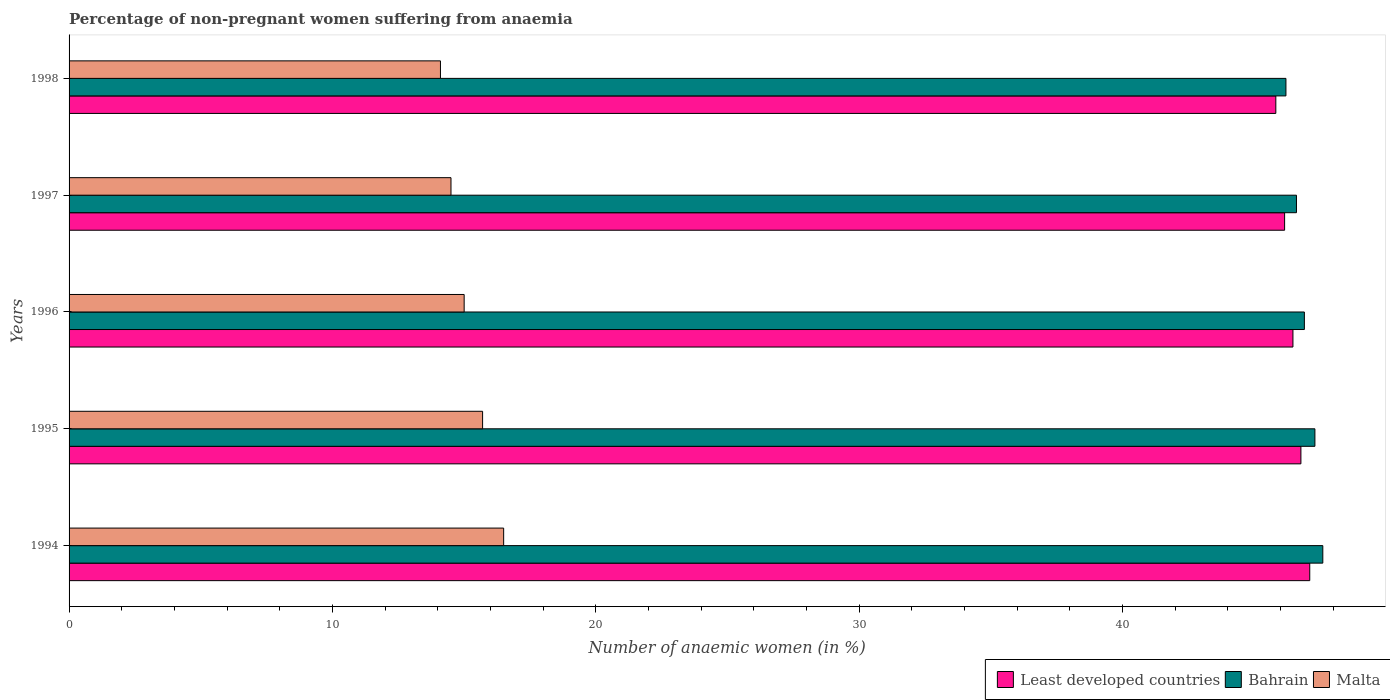How many groups of bars are there?
Make the answer very short. 5. Are the number of bars per tick equal to the number of legend labels?
Make the answer very short. Yes. Are the number of bars on each tick of the Y-axis equal?
Your answer should be compact. Yes. How many bars are there on the 5th tick from the top?
Your answer should be very brief. 3. How many bars are there on the 1st tick from the bottom?
Offer a very short reply. 3. In how many cases, is the number of bars for a given year not equal to the number of legend labels?
Provide a succinct answer. 0. What is the percentage of non-pregnant women suffering from anaemia in Bahrain in 1998?
Provide a succinct answer. 46.2. Across all years, what is the maximum percentage of non-pregnant women suffering from anaemia in Malta?
Give a very brief answer. 16.5. Across all years, what is the minimum percentage of non-pregnant women suffering from anaemia in Bahrain?
Provide a succinct answer. 46.2. In which year was the percentage of non-pregnant women suffering from anaemia in Bahrain maximum?
Offer a terse response. 1994. In which year was the percentage of non-pregnant women suffering from anaemia in Least developed countries minimum?
Offer a very short reply. 1998. What is the total percentage of non-pregnant women suffering from anaemia in Least developed countries in the graph?
Offer a very short reply. 232.3. What is the difference between the percentage of non-pregnant women suffering from anaemia in Least developed countries in 1996 and that in 1998?
Your answer should be compact. 0.65. What is the difference between the percentage of non-pregnant women suffering from anaemia in Least developed countries in 1997 and the percentage of non-pregnant women suffering from anaemia in Malta in 1995?
Offer a very short reply. 30.45. What is the average percentage of non-pregnant women suffering from anaemia in Least developed countries per year?
Offer a terse response. 46.46. In the year 1996, what is the difference between the percentage of non-pregnant women suffering from anaemia in Least developed countries and percentage of non-pregnant women suffering from anaemia in Bahrain?
Your response must be concise. -0.43. What is the ratio of the percentage of non-pregnant women suffering from anaemia in Bahrain in 1994 to that in 1996?
Provide a short and direct response. 1.01. Is the percentage of non-pregnant women suffering from anaemia in Least developed countries in 1994 less than that in 1998?
Your answer should be compact. No. Is the difference between the percentage of non-pregnant women suffering from anaemia in Least developed countries in 1994 and 1995 greater than the difference between the percentage of non-pregnant women suffering from anaemia in Bahrain in 1994 and 1995?
Offer a terse response. Yes. What is the difference between the highest and the second highest percentage of non-pregnant women suffering from anaemia in Least developed countries?
Your response must be concise. 0.34. What is the difference between the highest and the lowest percentage of non-pregnant women suffering from anaemia in Least developed countries?
Your answer should be very brief. 1.29. In how many years, is the percentage of non-pregnant women suffering from anaemia in Least developed countries greater than the average percentage of non-pregnant women suffering from anaemia in Least developed countries taken over all years?
Your response must be concise. 3. What does the 3rd bar from the top in 1994 represents?
Keep it short and to the point. Least developed countries. What does the 2nd bar from the bottom in 1997 represents?
Your response must be concise. Bahrain. Are all the bars in the graph horizontal?
Give a very brief answer. Yes. What is the difference between two consecutive major ticks on the X-axis?
Provide a short and direct response. 10. Does the graph contain any zero values?
Ensure brevity in your answer.  No. Where does the legend appear in the graph?
Offer a terse response. Bottom right. What is the title of the graph?
Offer a very short reply. Percentage of non-pregnant women suffering from anaemia. What is the label or title of the X-axis?
Your response must be concise. Number of anaemic women (in %). What is the Number of anaemic women (in %) in Least developed countries in 1994?
Your answer should be compact. 47.1. What is the Number of anaemic women (in %) of Bahrain in 1994?
Your answer should be compact. 47.6. What is the Number of anaemic women (in %) in Least developed countries in 1995?
Provide a succinct answer. 46.77. What is the Number of anaemic women (in %) in Bahrain in 1995?
Your response must be concise. 47.3. What is the Number of anaemic women (in %) in Malta in 1995?
Give a very brief answer. 15.7. What is the Number of anaemic women (in %) of Least developed countries in 1996?
Your response must be concise. 46.47. What is the Number of anaemic women (in %) in Bahrain in 1996?
Offer a very short reply. 46.9. What is the Number of anaemic women (in %) in Malta in 1996?
Your answer should be very brief. 15. What is the Number of anaemic women (in %) of Least developed countries in 1997?
Ensure brevity in your answer.  46.15. What is the Number of anaemic women (in %) of Bahrain in 1997?
Make the answer very short. 46.6. What is the Number of anaemic women (in %) in Least developed countries in 1998?
Keep it short and to the point. 45.82. What is the Number of anaemic women (in %) of Bahrain in 1998?
Keep it short and to the point. 46.2. What is the Number of anaemic women (in %) in Malta in 1998?
Provide a short and direct response. 14.1. Across all years, what is the maximum Number of anaemic women (in %) of Least developed countries?
Ensure brevity in your answer.  47.1. Across all years, what is the maximum Number of anaemic women (in %) of Bahrain?
Give a very brief answer. 47.6. Across all years, what is the maximum Number of anaemic women (in %) of Malta?
Keep it short and to the point. 16.5. Across all years, what is the minimum Number of anaemic women (in %) of Least developed countries?
Provide a short and direct response. 45.82. Across all years, what is the minimum Number of anaemic women (in %) in Bahrain?
Offer a very short reply. 46.2. Across all years, what is the minimum Number of anaemic women (in %) in Malta?
Offer a terse response. 14.1. What is the total Number of anaemic women (in %) in Least developed countries in the graph?
Your answer should be very brief. 232.3. What is the total Number of anaemic women (in %) in Bahrain in the graph?
Provide a short and direct response. 234.6. What is the total Number of anaemic women (in %) in Malta in the graph?
Provide a succinct answer. 75.8. What is the difference between the Number of anaemic women (in %) in Least developed countries in 1994 and that in 1995?
Make the answer very short. 0.34. What is the difference between the Number of anaemic women (in %) in Malta in 1994 and that in 1995?
Your answer should be compact. 0.8. What is the difference between the Number of anaemic women (in %) of Least developed countries in 1994 and that in 1996?
Your answer should be compact. 0.64. What is the difference between the Number of anaemic women (in %) of Bahrain in 1994 and that in 1996?
Offer a terse response. 0.7. What is the difference between the Number of anaemic women (in %) of Malta in 1994 and that in 1996?
Your answer should be compact. 1.5. What is the difference between the Number of anaemic women (in %) of Least developed countries in 1994 and that in 1997?
Provide a short and direct response. 0.95. What is the difference between the Number of anaemic women (in %) of Bahrain in 1994 and that in 1997?
Your response must be concise. 1. What is the difference between the Number of anaemic women (in %) of Least developed countries in 1994 and that in 1998?
Provide a short and direct response. 1.29. What is the difference between the Number of anaemic women (in %) in Least developed countries in 1995 and that in 1996?
Provide a succinct answer. 0.3. What is the difference between the Number of anaemic women (in %) in Malta in 1995 and that in 1996?
Your response must be concise. 0.7. What is the difference between the Number of anaemic women (in %) of Least developed countries in 1995 and that in 1997?
Provide a succinct answer. 0.62. What is the difference between the Number of anaemic women (in %) of Bahrain in 1995 and that in 1997?
Offer a terse response. 0.7. What is the difference between the Number of anaemic women (in %) in Malta in 1995 and that in 1997?
Keep it short and to the point. 1.2. What is the difference between the Number of anaemic women (in %) of Least developed countries in 1995 and that in 1998?
Ensure brevity in your answer.  0.95. What is the difference between the Number of anaemic women (in %) in Bahrain in 1995 and that in 1998?
Offer a terse response. 1.1. What is the difference between the Number of anaemic women (in %) of Malta in 1995 and that in 1998?
Give a very brief answer. 1.6. What is the difference between the Number of anaemic women (in %) in Least developed countries in 1996 and that in 1997?
Make the answer very short. 0.32. What is the difference between the Number of anaemic women (in %) in Malta in 1996 and that in 1997?
Your response must be concise. 0.5. What is the difference between the Number of anaemic women (in %) in Least developed countries in 1996 and that in 1998?
Make the answer very short. 0.65. What is the difference between the Number of anaemic women (in %) of Malta in 1996 and that in 1998?
Offer a very short reply. 0.9. What is the difference between the Number of anaemic women (in %) in Least developed countries in 1997 and that in 1998?
Offer a terse response. 0.33. What is the difference between the Number of anaemic women (in %) in Malta in 1997 and that in 1998?
Keep it short and to the point. 0.4. What is the difference between the Number of anaemic women (in %) of Least developed countries in 1994 and the Number of anaemic women (in %) of Bahrain in 1995?
Ensure brevity in your answer.  -0.2. What is the difference between the Number of anaemic women (in %) in Least developed countries in 1994 and the Number of anaemic women (in %) in Malta in 1995?
Offer a terse response. 31.4. What is the difference between the Number of anaemic women (in %) in Bahrain in 1994 and the Number of anaemic women (in %) in Malta in 1995?
Your response must be concise. 31.9. What is the difference between the Number of anaemic women (in %) of Least developed countries in 1994 and the Number of anaemic women (in %) of Bahrain in 1996?
Your response must be concise. 0.2. What is the difference between the Number of anaemic women (in %) of Least developed countries in 1994 and the Number of anaemic women (in %) of Malta in 1996?
Provide a succinct answer. 32.1. What is the difference between the Number of anaemic women (in %) of Bahrain in 1994 and the Number of anaemic women (in %) of Malta in 1996?
Provide a short and direct response. 32.6. What is the difference between the Number of anaemic women (in %) of Least developed countries in 1994 and the Number of anaemic women (in %) of Bahrain in 1997?
Offer a terse response. 0.5. What is the difference between the Number of anaemic women (in %) of Least developed countries in 1994 and the Number of anaemic women (in %) of Malta in 1997?
Give a very brief answer. 32.6. What is the difference between the Number of anaemic women (in %) in Bahrain in 1994 and the Number of anaemic women (in %) in Malta in 1997?
Offer a terse response. 33.1. What is the difference between the Number of anaemic women (in %) in Least developed countries in 1994 and the Number of anaemic women (in %) in Bahrain in 1998?
Provide a succinct answer. 0.9. What is the difference between the Number of anaemic women (in %) of Least developed countries in 1994 and the Number of anaemic women (in %) of Malta in 1998?
Provide a short and direct response. 33. What is the difference between the Number of anaemic women (in %) of Bahrain in 1994 and the Number of anaemic women (in %) of Malta in 1998?
Provide a succinct answer. 33.5. What is the difference between the Number of anaemic women (in %) in Least developed countries in 1995 and the Number of anaemic women (in %) in Bahrain in 1996?
Your response must be concise. -0.13. What is the difference between the Number of anaemic women (in %) of Least developed countries in 1995 and the Number of anaemic women (in %) of Malta in 1996?
Provide a succinct answer. 31.77. What is the difference between the Number of anaemic women (in %) of Bahrain in 1995 and the Number of anaemic women (in %) of Malta in 1996?
Your answer should be compact. 32.3. What is the difference between the Number of anaemic women (in %) in Least developed countries in 1995 and the Number of anaemic women (in %) in Bahrain in 1997?
Ensure brevity in your answer.  0.17. What is the difference between the Number of anaemic women (in %) of Least developed countries in 1995 and the Number of anaemic women (in %) of Malta in 1997?
Make the answer very short. 32.27. What is the difference between the Number of anaemic women (in %) of Bahrain in 1995 and the Number of anaemic women (in %) of Malta in 1997?
Offer a terse response. 32.8. What is the difference between the Number of anaemic women (in %) in Least developed countries in 1995 and the Number of anaemic women (in %) in Bahrain in 1998?
Offer a terse response. 0.57. What is the difference between the Number of anaemic women (in %) in Least developed countries in 1995 and the Number of anaemic women (in %) in Malta in 1998?
Provide a succinct answer. 32.67. What is the difference between the Number of anaemic women (in %) in Bahrain in 1995 and the Number of anaemic women (in %) in Malta in 1998?
Your response must be concise. 33.2. What is the difference between the Number of anaemic women (in %) of Least developed countries in 1996 and the Number of anaemic women (in %) of Bahrain in 1997?
Your answer should be very brief. -0.13. What is the difference between the Number of anaemic women (in %) in Least developed countries in 1996 and the Number of anaemic women (in %) in Malta in 1997?
Provide a succinct answer. 31.97. What is the difference between the Number of anaemic women (in %) of Bahrain in 1996 and the Number of anaemic women (in %) of Malta in 1997?
Make the answer very short. 32.4. What is the difference between the Number of anaemic women (in %) of Least developed countries in 1996 and the Number of anaemic women (in %) of Bahrain in 1998?
Make the answer very short. 0.27. What is the difference between the Number of anaemic women (in %) in Least developed countries in 1996 and the Number of anaemic women (in %) in Malta in 1998?
Give a very brief answer. 32.37. What is the difference between the Number of anaemic women (in %) of Bahrain in 1996 and the Number of anaemic women (in %) of Malta in 1998?
Your response must be concise. 32.8. What is the difference between the Number of anaemic women (in %) of Least developed countries in 1997 and the Number of anaemic women (in %) of Bahrain in 1998?
Provide a succinct answer. -0.05. What is the difference between the Number of anaemic women (in %) of Least developed countries in 1997 and the Number of anaemic women (in %) of Malta in 1998?
Offer a terse response. 32.05. What is the difference between the Number of anaemic women (in %) of Bahrain in 1997 and the Number of anaemic women (in %) of Malta in 1998?
Make the answer very short. 32.5. What is the average Number of anaemic women (in %) of Least developed countries per year?
Provide a short and direct response. 46.46. What is the average Number of anaemic women (in %) of Bahrain per year?
Provide a succinct answer. 46.92. What is the average Number of anaemic women (in %) of Malta per year?
Offer a terse response. 15.16. In the year 1994, what is the difference between the Number of anaemic women (in %) of Least developed countries and Number of anaemic women (in %) of Bahrain?
Provide a succinct answer. -0.5. In the year 1994, what is the difference between the Number of anaemic women (in %) in Least developed countries and Number of anaemic women (in %) in Malta?
Offer a very short reply. 30.6. In the year 1994, what is the difference between the Number of anaemic women (in %) in Bahrain and Number of anaemic women (in %) in Malta?
Keep it short and to the point. 31.1. In the year 1995, what is the difference between the Number of anaemic women (in %) in Least developed countries and Number of anaemic women (in %) in Bahrain?
Your answer should be very brief. -0.53. In the year 1995, what is the difference between the Number of anaemic women (in %) of Least developed countries and Number of anaemic women (in %) of Malta?
Make the answer very short. 31.07. In the year 1995, what is the difference between the Number of anaemic women (in %) in Bahrain and Number of anaemic women (in %) in Malta?
Provide a short and direct response. 31.6. In the year 1996, what is the difference between the Number of anaemic women (in %) in Least developed countries and Number of anaemic women (in %) in Bahrain?
Provide a short and direct response. -0.43. In the year 1996, what is the difference between the Number of anaemic women (in %) of Least developed countries and Number of anaemic women (in %) of Malta?
Your answer should be compact. 31.47. In the year 1996, what is the difference between the Number of anaemic women (in %) in Bahrain and Number of anaemic women (in %) in Malta?
Your answer should be compact. 31.9. In the year 1997, what is the difference between the Number of anaemic women (in %) in Least developed countries and Number of anaemic women (in %) in Bahrain?
Your response must be concise. -0.45. In the year 1997, what is the difference between the Number of anaemic women (in %) in Least developed countries and Number of anaemic women (in %) in Malta?
Provide a succinct answer. 31.65. In the year 1997, what is the difference between the Number of anaemic women (in %) of Bahrain and Number of anaemic women (in %) of Malta?
Ensure brevity in your answer.  32.1. In the year 1998, what is the difference between the Number of anaemic women (in %) in Least developed countries and Number of anaemic women (in %) in Bahrain?
Give a very brief answer. -0.38. In the year 1998, what is the difference between the Number of anaemic women (in %) in Least developed countries and Number of anaemic women (in %) in Malta?
Offer a terse response. 31.72. In the year 1998, what is the difference between the Number of anaemic women (in %) in Bahrain and Number of anaemic women (in %) in Malta?
Keep it short and to the point. 32.1. What is the ratio of the Number of anaemic women (in %) in Least developed countries in 1994 to that in 1995?
Make the answer very short. 1.01. What is the ratio of the Number of anaemic women (in %) of Malta in 1994 to that in 1995?
Offer a terse response. 1.05. What is the ratio of the Number of anaemic women (in %) of Least developed countries in 1994 to that in 1996?
Give a very brief answer. 1.01. What is the ratio of the Number of anaemic women (in %) of Bahrain in 1994 to that in 1996?
Your answer should be compact. 1.01. What is the ratio of the Number of anaemic women (in %) in Least developed countries in 1994 to that in 1997?
Ensure brevity in your answer.  1.02. What is the ratio of the Number of anaemic women (in %) in Bahrain in 1994 to that in 1997?
Your answer should be very brief. 1.02. What is the ratio of the Number of anaemic women (in %) of Malta in 1994 to that in 1997?
Your answer should be compact. 1.14. What is the ratio of the Number of anaemic women (in %) in Least developed countries in 1994 to that in 1998?
Your response must be concise. 1.03. What is the ratio of the Number of anaemic women (in %) of Bahrain in 1994 to that in 1998?
Offer a terse response. 1.03. What is the ratio of the Number of anaemic women (in %) in Malta in 1994 to that in 1998?
Give a very brief answer. 1.17. What is the ratio of the Number of anaemic women (in %) in Least developed countries in 1995 to that in 1996?
Your response must be concise. 1.01. What is the ratio of the Number of anaemic women (in %) of Bahrain in 1995 to that in 1996?
Make the answer very short. 1.01. What is the ratio of the Number of anaemic women (in %) in Malta in 1995 to that in 1996?
Provide a short and direct response. 1.05. What is the ratio of the Number of anaemic women (in %) in Least developed countries in 1995 to that in 1997?
Your answer should be compact. 1.01. What is the ratio of the Number of anaemic women (in %) in Malta in 1995 to that in 1997?
Offer a terse response. 1.08. What is the ratio of the Number of anaemic women (in %) in Least developed countries in 1995 to that in 1998?
Make the answer very short. 1.02. What is the ratio of the Number of anaemic women (in %) in Bahrain in 1995 to that in 1998?
Ensure brevity in your answer.  1.02. What is the ratio of the Number of anaemic women (in %) of Malta in 1995 to that in 1998?
Provide a short and direct response. 1.11. What is the ratio of the Number of anaemic women (in %) in Bahrain in 1996 to that in 1997?
Keep it short and to the point. 1.01. What is the ratio of the Number of anaemic women (in %) in Malta in 1996 to that in 1997?
Offer a terse response. 1.03. What is the ratio of the Number of anaemic women (in %) in Least developed countries in 1996 to that in 1998?
Your response must be concise. 1.01. What is the ratio of the Number of anaemic women (in %) of Bahrain in 1996 to that in 1998?
Your response must be concise. 1.02. What is the ratio of the Number of anaemic women (in %) in Malta in 1996 to that in 1998?
Keep it short and to the point. 1.06. What is the ratio of the Number of anaemic women (in %) of Least developed countries in 1997 to that in 1998?
Provide a short and direct response. 1.01. What is the ratio of the Number of anaemic women (in %) of Bahrain in 1997 to that in 1998?
Keep it short and to the point. 1.01. What is the ratio of the Number of anaemic women (in %) in Malta in 1997 to that in 1998?
Your answer should be very brief. 1.03. What is the difference between the highest and the second highest Number of anaemic women (in %) of Least developed countries?
Provide a short and direct response. 0.34. What is the difference between the highest and the second highest Number of anaemic women (in %) in Bahrain?
Give a very brief answer. 0.3. What is the difference between the highest and the lowest Number of anaemic women (in %) in Least developed countries?
Your response must be concise. 1.29. What is the difference between the highest and the lowest Number of anaemic women (in %) in Bahrain?
Keep it short and to the point. 1.4. What is the difference between the highest and the lowest Number of anaemic women (in %) in Malta?
Make the answer very short. 2.4. 